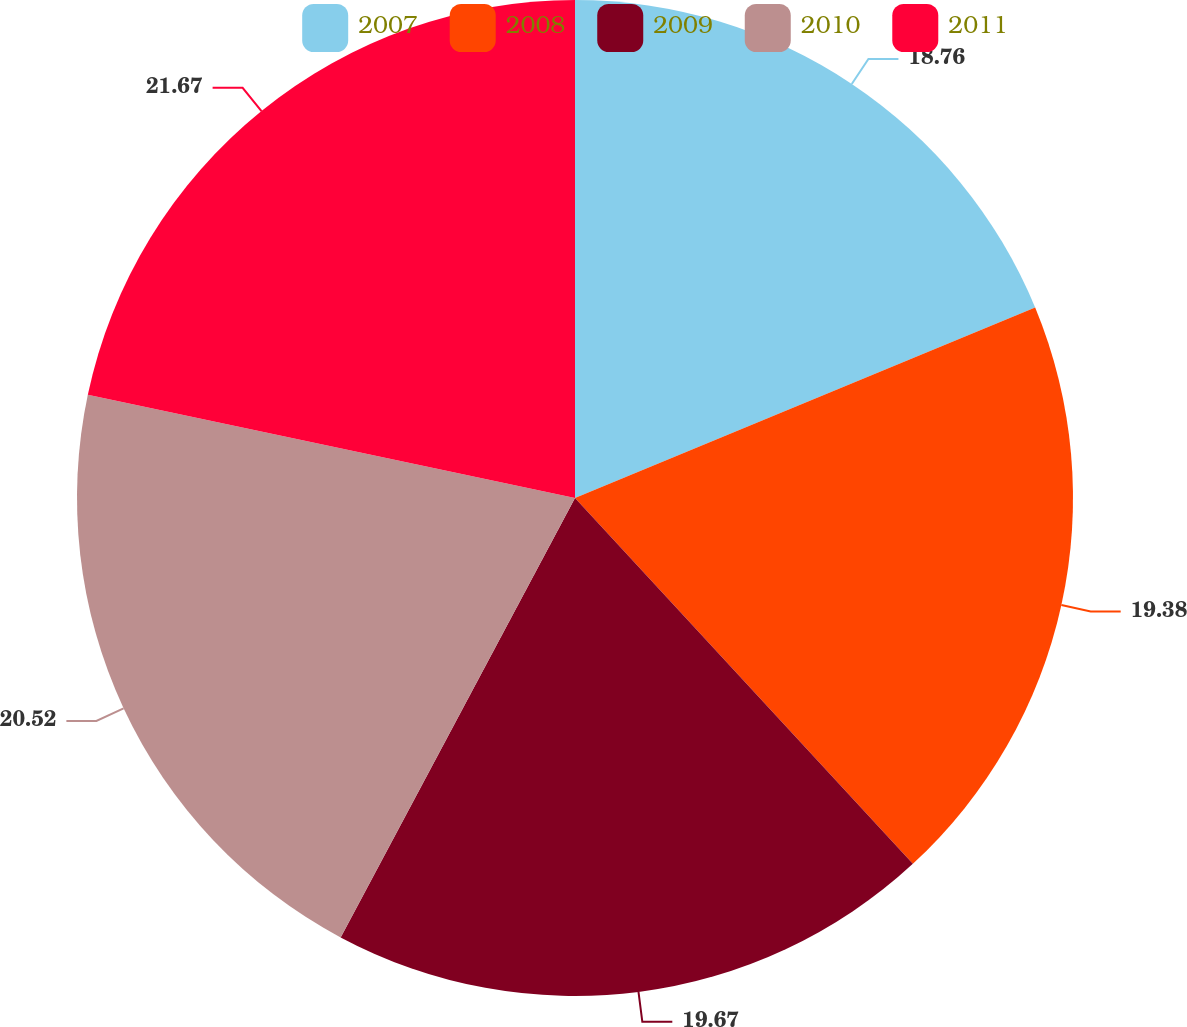Convert chart to OTSL. <chart><loc_0><loc_0><loc_500><loc_500><pie_chart><fcel>2007<fcel>2008<fcel>2009<fcel>2010<fcel>2011<nl><fcel>18.76%<fcel>19.38%<fcel>19.67%<fcel>20.53%<fcel>21.68%<nl></chart> 